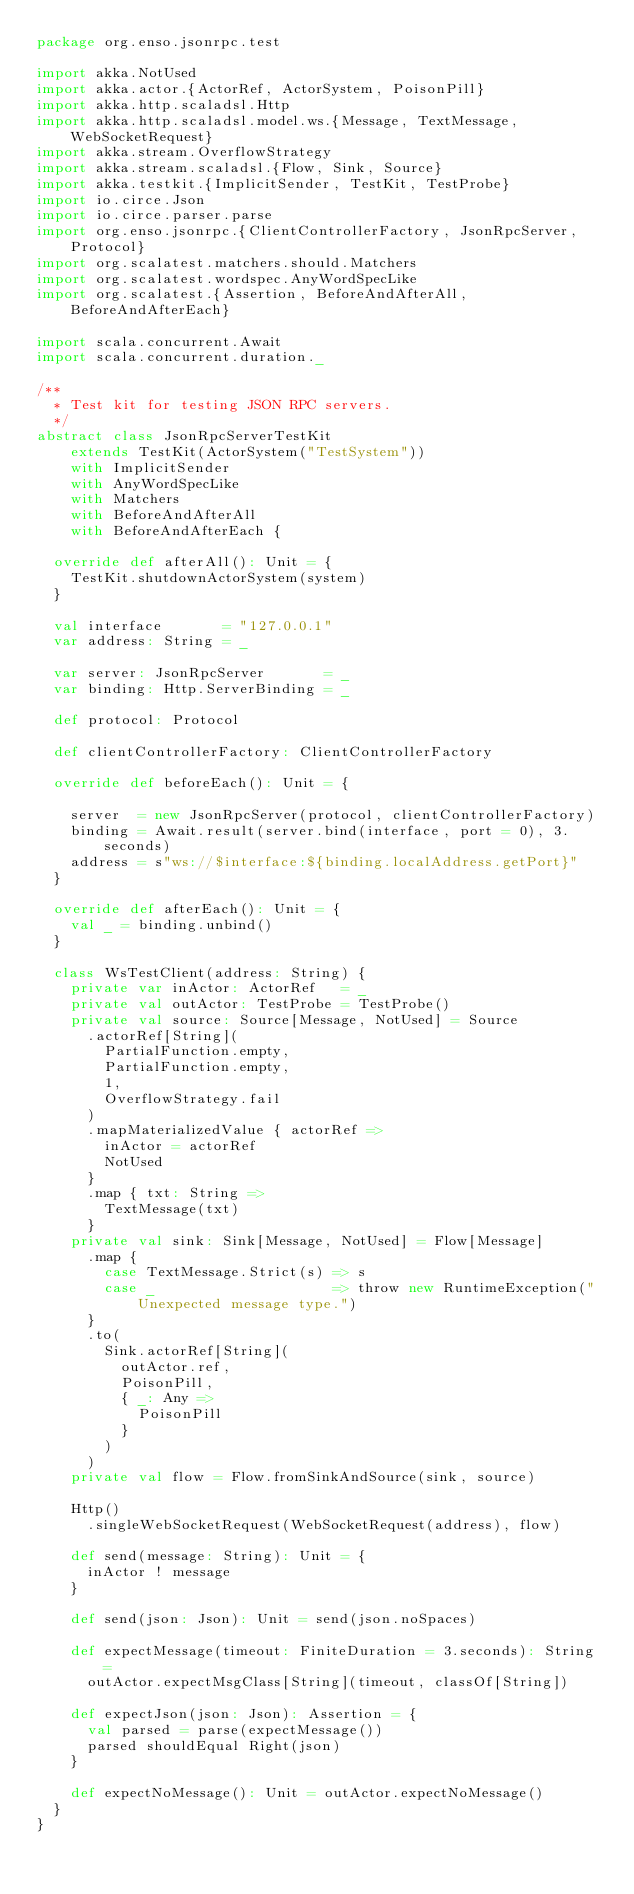<code> <loc_0><loc_0><loc_500><loc_500><_Scala_>package org.enso.jsonrpc.test

import akka.NotUsed
import akka.actor.{ActorRef, ActorSystem, PoisonPill}
import akka.http.scaladsl.Http
import akka.http.scaladsl.model.ws.{Message, TextMessage, WebSocketRequest}
import akka.stream.OverflowStrategy
import akka.stream.scaladsl.{Flow, Sink, Source}
import akka.testkit.{ImplicitSender, TestKit, TestProbe}
import io.circe.Json
import io.circe.parser.parse
import org.enso.jsonrpc.{ClientControllerFactory, JsonRpcServer, Protocol}
import org.scalatest.matchers.should.Matchers
import org.scalatest.wordspec.AnyWordSpecLike
import org.scalatest.{Assertion, BeforeAndAfterAll, BeforeAndAfterEach}

import scala.concurrent.Await
import scala.concurrent.duration._

/**
  * Test kit for testing JSON RPC servers.
  */
abstract class JsonRpcServerTestKit
    extends TestKit(ActorSystem("TestSystem"))
    with ImplicitSender
    with AnyWordSpecLike
    with Matchers
    with BeforeAndAfterAll
    with BeforeAndAfterEach {

  override def afterAll(): Unit = {
    TestKit.shutdownActorSystem(system)
  }

  val interface       = "127.0.0.1"
  var address: String = _

  var server: JsonRpcServer       = _
  var binding: Http.ServerBinding = _

  def protocol: Protocol

  def clientControllerFactory: ClientControllerFactory

  override def beforeEach(): Unit = {

    server  = new JsonRpcServer(protocol, clientControllerFactory)
    binding = Await.result(server.bind(interface, port = 0), 3.seconds)
    address = s"ws://$interface:${binding.localAddress.getPort}"
  }

  override def afterEach(): Unit = {
    val _ = binding.unbind()
  }

  class WsTestClient(address: String) {
    private var inActor: ActorRef   = _
    private val outActor: TestProbe = TestProbe()
    private val source: Source[Message, NotUsed] = Source
      .actorRef[String](
        PartialFunction.empty,
        PartialFunction.empty,
        1,
        OverflowStrategy.fail
      )
      .mapMaterializedValue { actorRef =>
        inActor = actorRef
        NotUsed
      }
      .map { txt: String =>
        TextMessage(txt)
      }
    private val sink: Sink[Message, NotUsed] = Flow[Message]
      .map {
        case TextMessage.Strict(s) => s
        case _                     => throw new RuntimeException("Unexpected message type.")
      }
      .to(
        Sink.actorRef[String](
          outActor.ref,
          PoisonPill,
          { _: Any =>
            PoisonPill
          }
        )
      )
    private val flow = Flow.fromSinkAndSource(sink, source)

    Http()
      .singleWebSocketRequest(WebSocketRequest(address), flow)

    def send(message: String): Unit = {
      inActor ! message
    }

    def send(json: Json): Unit = send(json.noSpaces)

    def expectMessage(timeout: FiniteDuration = 3.seconds): String =
      outActor.expectMsgClass[String](timeout, classOf[String])

    def expectJson(json: Json): Assertion = {
      val parsed = parse(expectMessage())
      parsed shouldEqual Right(json)
    }

    def expectNoMessage(): Unit = outActor.expectNoMessage()
  }
}
</code> 